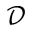<formula> <loc_0><loc_0><loc_500><loc_500>\mathcal { D }</formula> 